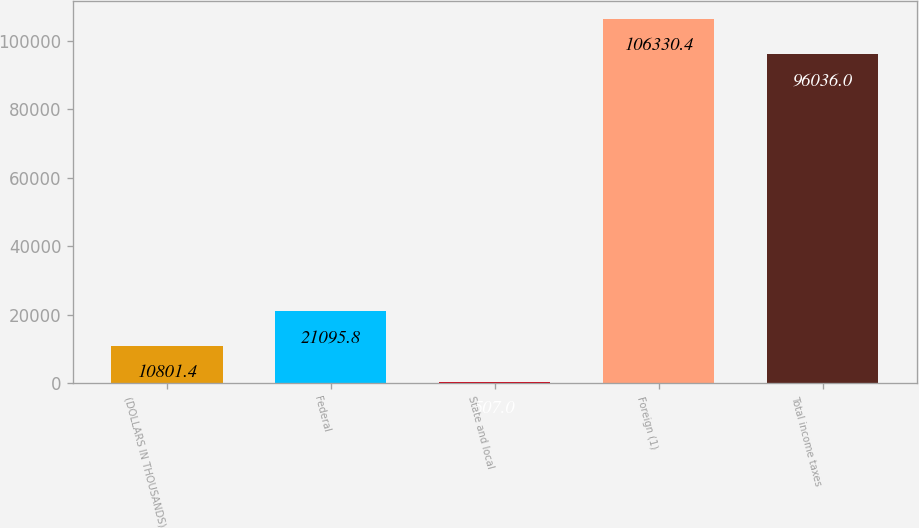<chart> <loc_0><loc_0><loc_500><loc_500><bar_chart><fcel>(DOLLARS IN THOUSANDS)<fcel>Federal<fcel>State and local<fcel>Foreign (1)<fcel>Total income taxes<nl><fcel>10801.4<fcel>21095.8<fcel>507<fcel>106330<fcel>96036<nl></chart> 